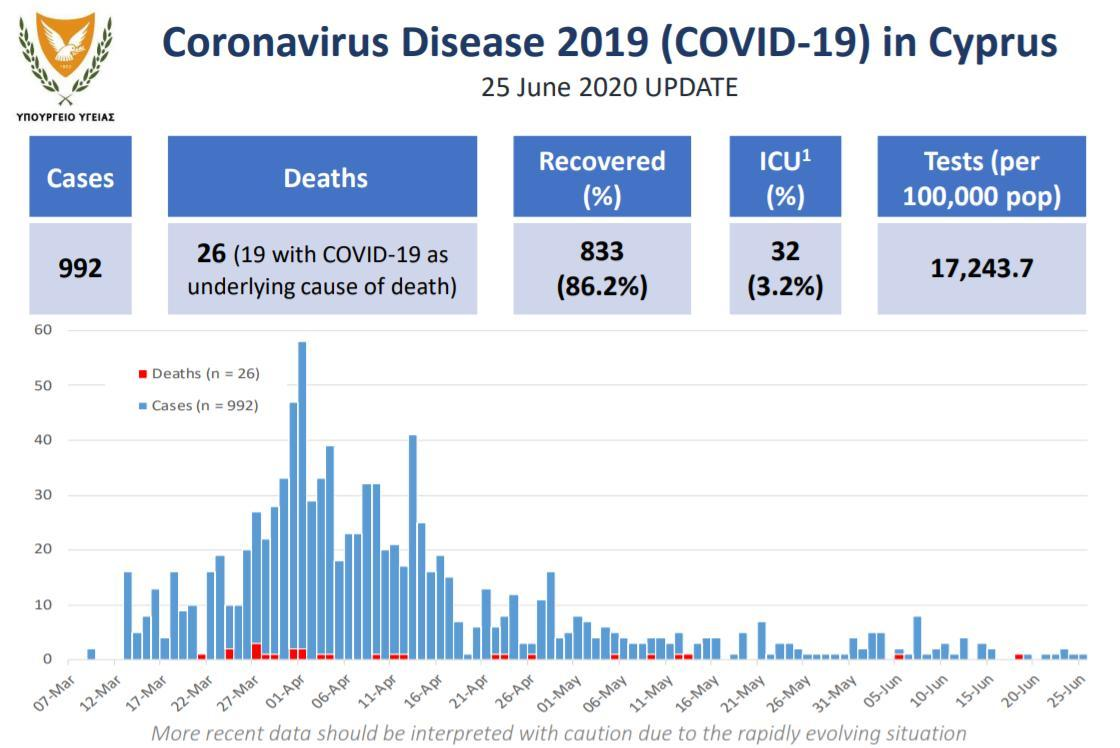What has been the count of tests per 100,000 pop
Answer the question with a short phrase. 17,243.7 Out of 26 deaths, how many were deaths where the underlying cause was not COVID-19 7 In which month was the highest death count on a particular day reported Mar What % of cases were in ICU 3.2% What is the recovery % 86.2% 